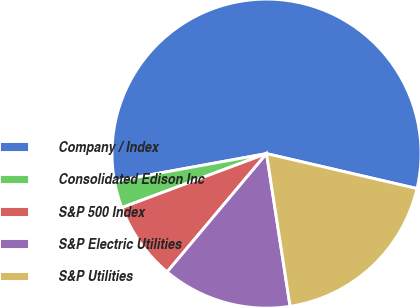<chart> <loc_0><loc_0><loc_500><loc_500><pie_chart><fcel>Company / Index<fcel>Consolidated Edison Inc<fcel>S&P 500 Index<fcel>S&P Electric Utilities<fcel>S&P Utilities<nl><fcel>56.5%<fcel>2.82%<fcel>8.19%<fcel>13.56%<fcel>18.93%<nl></chart> 